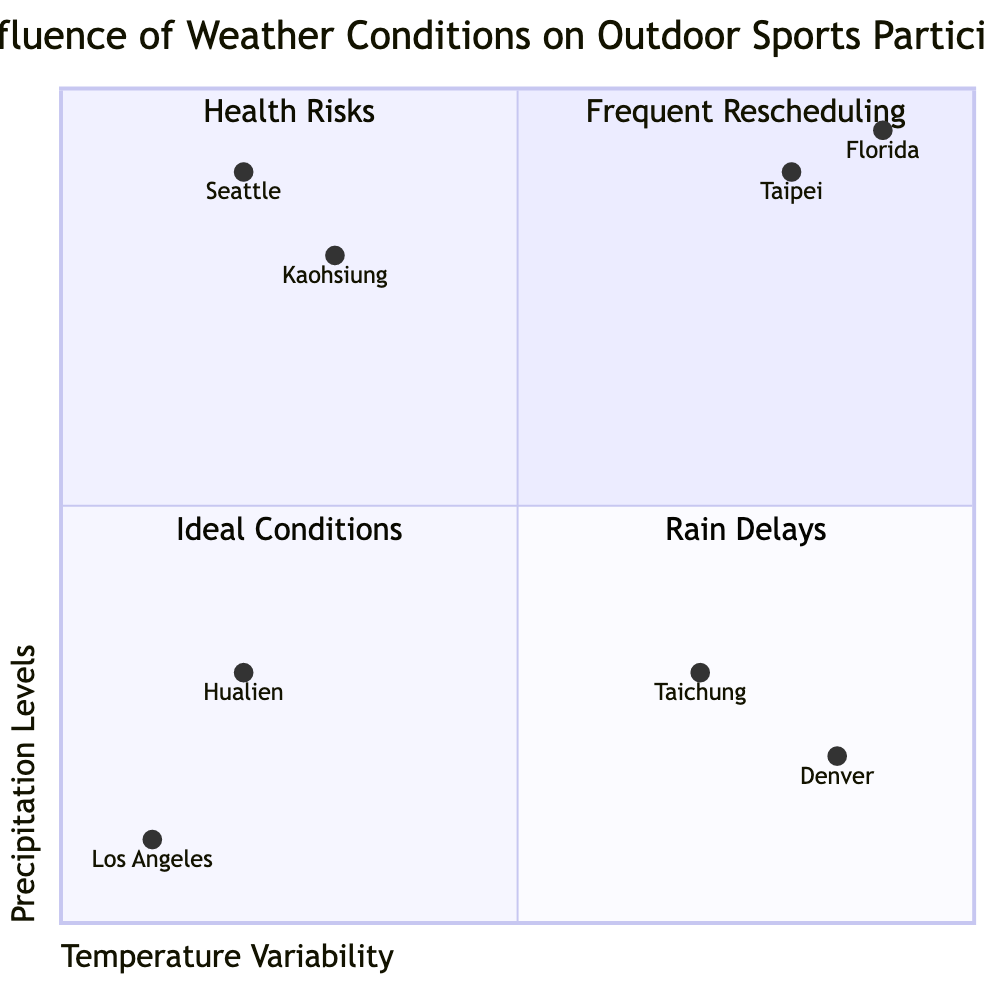What is the quadrant for Taipei? Analyzing the coordinates for Taipei, which are [0.8, 0.9], we find that it falls into the area of high temperature variability (X-axis) and high precipitation levels (Y-axis). This places Taipei in the quadrant labeled "Frequent Rescheduling."
Answer: Frequent Rescheduling Which city has the highest precipitation levels? Looking at the precipitation values for each city, Florida has the highest at 0.95. Therefore, Florida is the city with the highest precipitation levels.
Answer: Florida How many regions have low temperature variability? Reviewing the listed examples, we see that the cities with low temperature variability are Kaohsiung, Hualien, and Los Angeles. Counting these examples gives us a total of three regions.
Answer: 3 What are the implications for sports participation in regions with low precipitation and low temperature variability? The quadrant describing low temperature variability and low precipitation lists several positive implications for sports participation, including consistency in activities and minimal scheduling adjustments. This indicates favorable conditions for outdoor sports.
Answer: Ideal Conditions Which U.S. city is located in the "Health Risks" quadrant? Analyzing the placement of U.S. cities on the diagram, Denver, with coordinates [0.85, 0.2], falls into the “High Temperature Variability, Low Precipitation Levels” quadrant, which is designated as "Health Risks."
Answer: Denver What type of weather conditions does Seattle experience in relation to outdoor sports? In the quadrant chart's analysis, Seattle is categorized under "Low Temperature Variability, High Precipitation Levels," indicating it typically faces rainfall, which affects outdoor sports participation.
Answer: Rain Delays Which region has a balance of stability in temperature and minimal rainfall for outdoor sports? Hualien, with coordinates [0.2, 0.3], represents an area with low temperature variability and low precipitation levels, making it ideal for outdoor sports participation.
Answer: Hualien What can be inferred about outdoor sports participation in Taichung during spring? The coordinates for Taichung are [0.7, 0.3], placing it in the "Health Risks" quadrant. This indicates temperature variability poses potential health risks for participants during this time.
Answer: Health Risks Which region needs the most waterproof gear and apparel for sports? Kaohsiung, with high precipitation levels but stable temperatures, necessitates frequent use of waterproof gear due to regular rainfall, placing it in the "Rain Delays" quadrant.
Answer: Kaohsiung What defines the "Frequent Rescheduling" quadrant? The "Frequent Rescheduling" quadrant is defined by high temperature variability combined with high precipitation levels, as seen in cities like Taipei and Florida. These conditions lead to unpredictable weather affecting sports schedules.
Answer: High Temperature Variability, High Precipitation Levels 